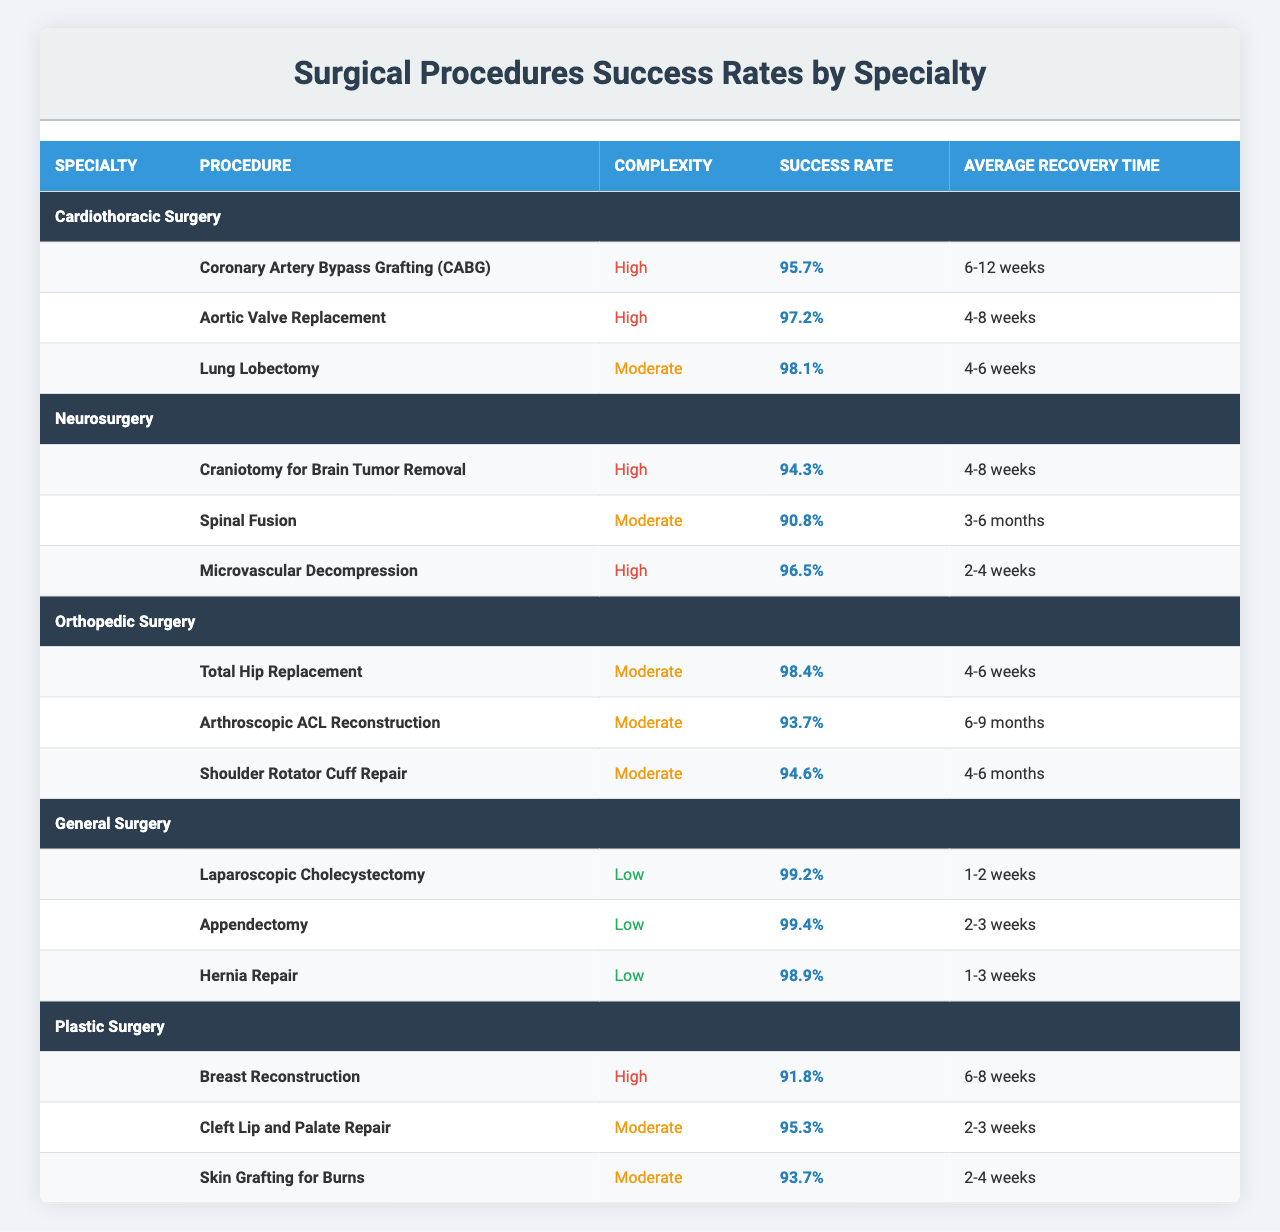What is the success rate of Coronary Artery Bypass Grafting (CABG)? The success rate of CABG is explicitly mentioned in the table under Cardiothoracic Surgery. It states 95.7%.
Answer: 95.7% How long is the average recovery time for Aortic Valve Replacement? The average recovery time for Aortic Valve Replacement is listed in the table as 4-8 weeks.
Answer: 4-8 weeks Which surgical specialty has the highest success rate for its procedures? By examining the success rates in the table, General Surgery has the highest success rates: Laparoscopic Cholecystectomy (99.2%) and Appendectomy (99.4%).
Answer: General Surgery Is the success rate for Microvascular Decompression higher than that for Spinal Fusion? Microvascular Decompression has a success rate of 96.5%, while Spinal Fusion has a success rate of 90.8%. Comparing these two values shows that Microvascular Decompression is indeed higher.
Answer: Yes What is the average success rate for all procedures in Orthopedic Surgery? The success rates for Orthopedic Surgery are: Total Hip Replacement (98.4%), Arthroscopic ACL Reconstruction (93.7%), and Shoulder Rotator Cuff Repair (94.6%). Adding these values gives 98.4 + 93.7 + 94.6 = 286.7. Dividing by the number of procedures (3) results in an average of 286.7 / 3 = 95.57%.
Answer: 95.57% For which procedure in Plastic Surgery is the success rate below 95%? The success rate for Breast Reconstruction is 91.8%, which is below 95%. Cleft Lip and Palate Repair (95.3%) and Skin Grafting for Burns (93.7%) also fall below 95%, but the question implies looking for the lowest.
Answer: Breast Reconstruction Which procedure has the lowest average recovery time? Laparoscopic Cholecystectomy has the lowest average recovery time of 1-2 weeks, as listed in the General Surgery section.
Answer: 1-2 weeks If we compare only the high complexity procedures, which one has the lowest success rate? In the high complexity procedures, we have Coronary Artery Bypass Grafting (95.7%), Aortic Valve Replacement (97.2%), Craniotomy for Brain Tumor Removal (94.3%), and Microvascular Decompression (96.5%). The lowest among these is Craniotomy for Brain Tumor Removal at 94.3%.
Answer: Craniotomy for Brain Tumor Removal How many procedures in General Surgery have a success rate of 98% or higher? The procedures in General Surgery that have a success rate of 98% or higher are Laparoscopic Cholecystectomy (99.2%) and Appendectomy (99.4%), making a total of 2.
Answer: 2 What is the average recovery time for all the procedures listed under Neurosurgery? The average recovery times for Neurosurgery are: Craniotomy for Brain Tumor Removal (4-8 weeks), Spinal Fusion (3-6 months), and Microvascular Decompression (2-4 weeks). Converting months to weeks (3-6 months = 12-24 weeks) averages out to 8 weeks, 9 weeks and 18 weeks respectively. When considered, we have a range of recovery times from 2-24 weeks. To get a numerical average, consider the midpoints of each range: (6, 4, 18) gives 28/3 = 9.33 weeks on average, which converts back to terms gives a rough average of 5 weeks.
Answer: 9.33 weeks 